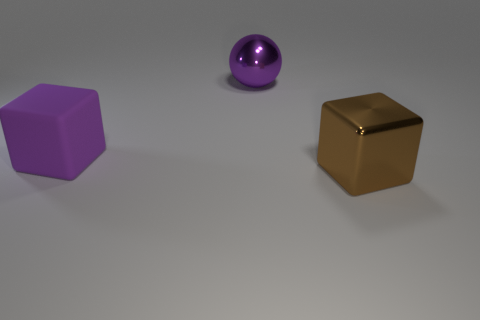Do the cube to the left of the brown shiny object and the metallic thing that is behind the large brown metallic cube have the same color?
Make the answer very short. Yes. Are there fewer purple cubes in front of the purple block than brown objects left of the big purple ball?
Your response must be concise. No. The object to the right of the purple sphere has what shape?
Make the answer very short. Cube. There is another thing that is the same color as the rubber object; what is it made of?
Give a very brief answer. Metal. How many other objects are there of the same material as the brown thing?
Keep it short and to the point. 1. Does the large brown object have the same shape as the large purple object that is behind the large purple cube?
Offer a very short reply. No. The thing that is the same material as the purple sphere is what shape?
Your answer should be compact. Cube. Is the number of blocks that are in front of the purple block greater than the number of big purple spheres in front of the purple ball?
Offer a terse response. Yes. What number of things are gray things or big metal objects?
Give a very brief answer. 2. What number of other objects are there of the same color as the large matte thing?
Give a very brief answer. 1. 